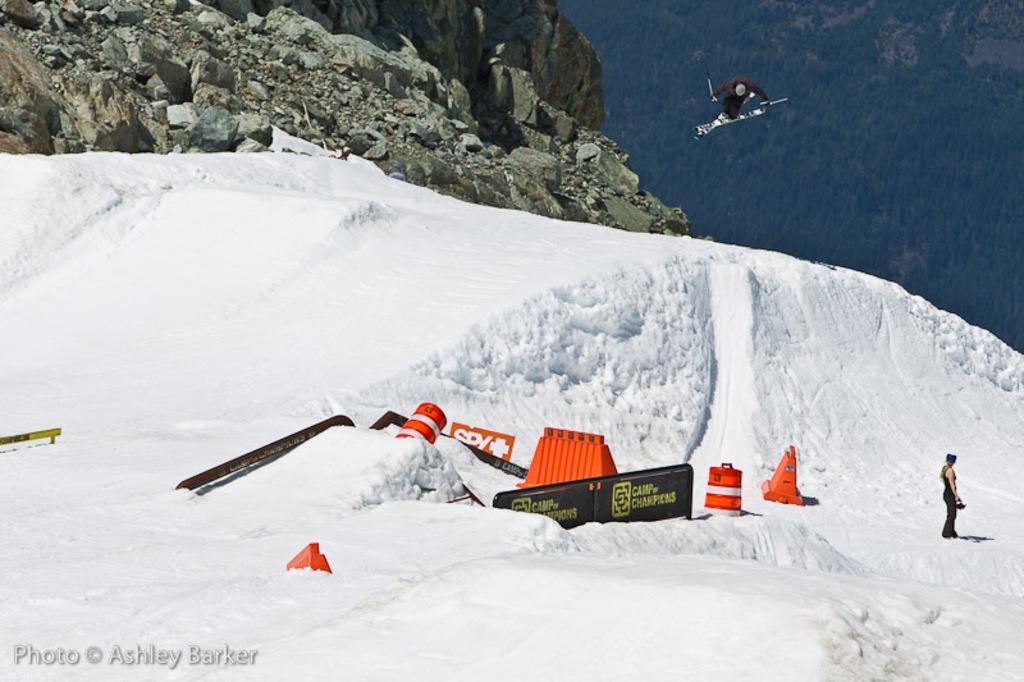Describe this image in one or two sentences. In this image, I can see a person in the air with ski board and ski poles. On the right side of the image, there is another person standing. There are barricades on the snow. In the background, there are mountains with rocks and trees. At the bottom left side of the image, I can see a watermark. 